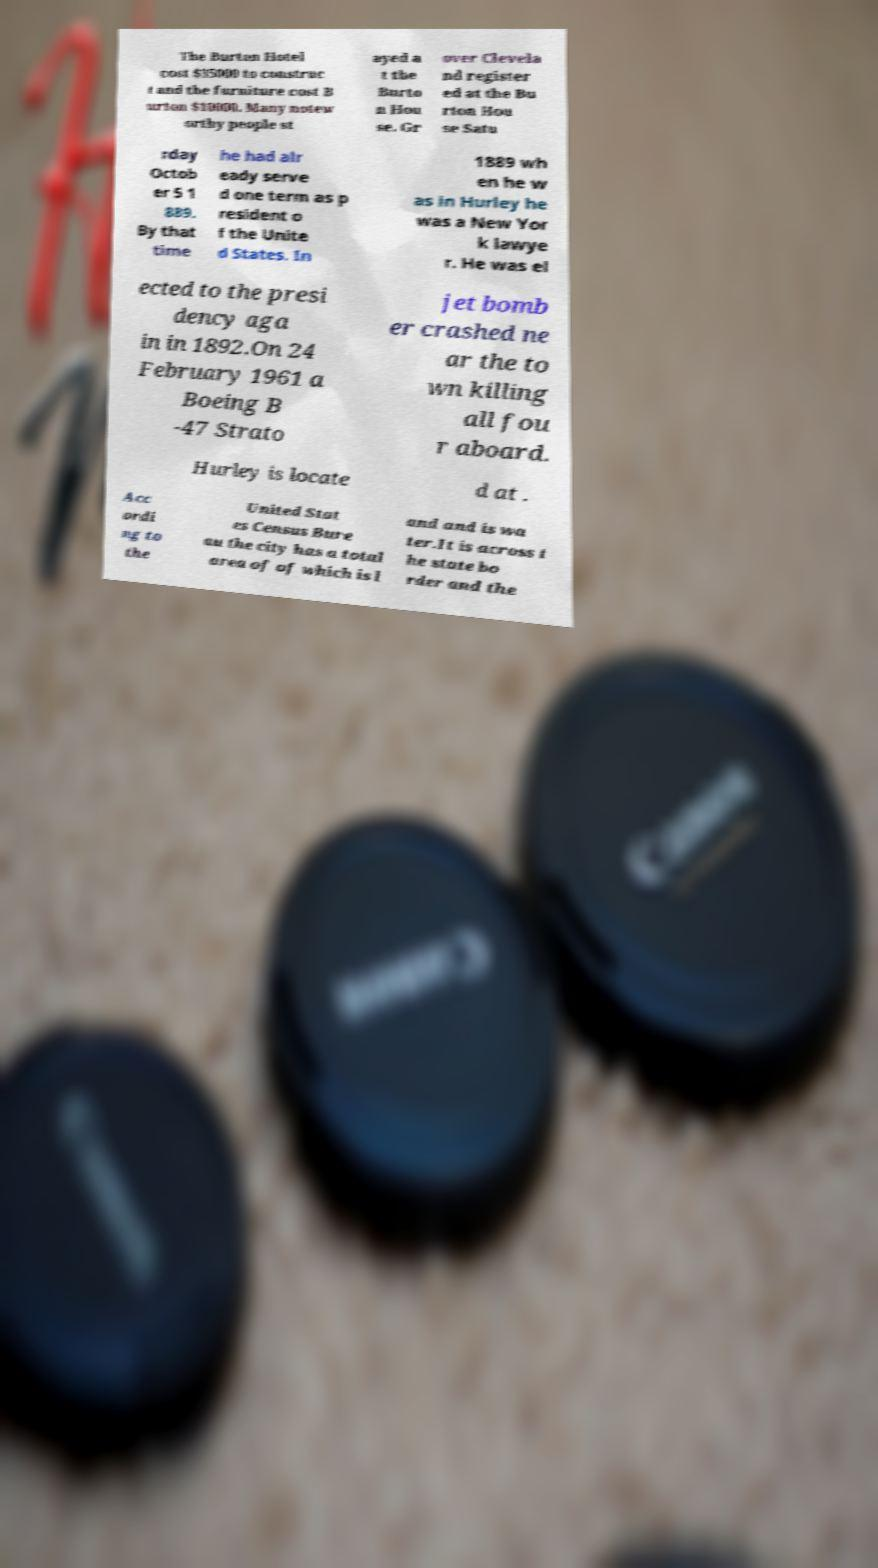I need the written content from this picture converted into text. Can you do that? The Burton Hotel cost $35000 to construc t and the furniture cost B urton $10000. Many notew orthy people st ayed a t the Burto n Hou se. Gr over Clevela nd register ed at the Bu rton Hou se Satu rday Octob er 5 1 889. By that time he had alr eady serve d one term as p resident o f the Unite d States. In 1889 wh en he w as in Hurley he was a New Yor k lawye r. He was el ected to the presi dency aga in in 1892.On 24 February 1961 a Boeing B -47 Strato jet bomb er crashed ne ar the to wn killing all fou r aboard. Hurley is locate d at . Acc ordi ng to the United Stat es Census Bure au the city has a total area of of which is l and and is wa ter.It is across t he state bo rder and the 